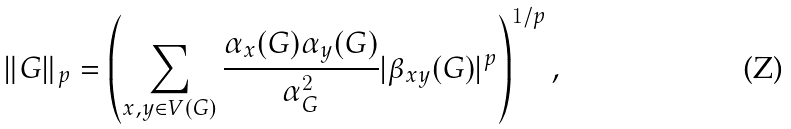Convert formula to latex. <formula><loc_0><loc_0><loc_500><loc_500>\| G \| _ { p } = \left ( \sum _ { x , y \in V ( G ) } \frac { \alpha _ { x } ( G ) \alpha _ { y } ( G ) } { \alpha _ { G } ^ { 2 } } | \beta _ { x y } ( G ) | ^ { p } \right ) ^ { 1 / p } ,</formula> 